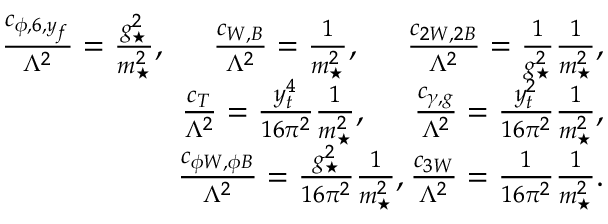<formula> <loc_0><loc_0><loc_500><loc_500>\begin{array} { r l r } & { \frac { c _ { \phi , 6 , y _ { f } } } { \Lambda ^ { 2 } } = \frac { g _ { ^ { * } } ^ { 2 } } { m _ { ^ { * } } ^ { 2 } } , \, \frac { c _ { W , B } } { \Lambda ^ { 2 } } = \frac { 1 } { m _ { ^ { * } } ^ { 2 } } , \, \frac { c _ { 2 W , 2 B } } { \Lambda ^ { 2 } } = \frac { 1 } { g _ { ^ { * } } ^ { 2 } } \frac { 1 } { m _ { ^ { * } } ^ { 2 } } , } \\ & { \frac { c _ { T } } { \Lambda ^ { 2 } } = \frac { y _ { t } ^ { 4 } } { 1 6 \pi ^ { 2 } } \frac { 1 } { m _ { ^ { * } } ^ { 2 } } , \, \frac { c _ { \gamma , g } } { \Lambda ^ { 2 } } = \frac { y _ { t } ^ { 2 } } { 1 6 \pi ^ { 2 } } \frac { 1 } { m _ { ^ { * } } ^ { 2 } } , } \\ & { \frac { c _ { \phi W , \phi B } } { \Lambda ^ { 2 } } = \frac { g _ { ^ { * } } ^ { 2 } } { 1 6 \pi ^ { 2 } } \frac { 1 } { m _ { ^ { * } } ^ { 2 } } , \frac { c _ { 3 W } } { \Lambda ^ { 2 } } = \frac { 1 } { 1 6 \pi ^ { 2 } } \frac { 1 } { m _ { ^ { * } } ^ { 2 } } . } \end{array}</formula> 